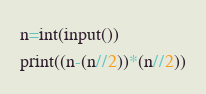<code> <loc_0><loc_0><loc_500><loc_500><_Python_>n=int(input())
print((n-(n//2))*(n//2))</code> 